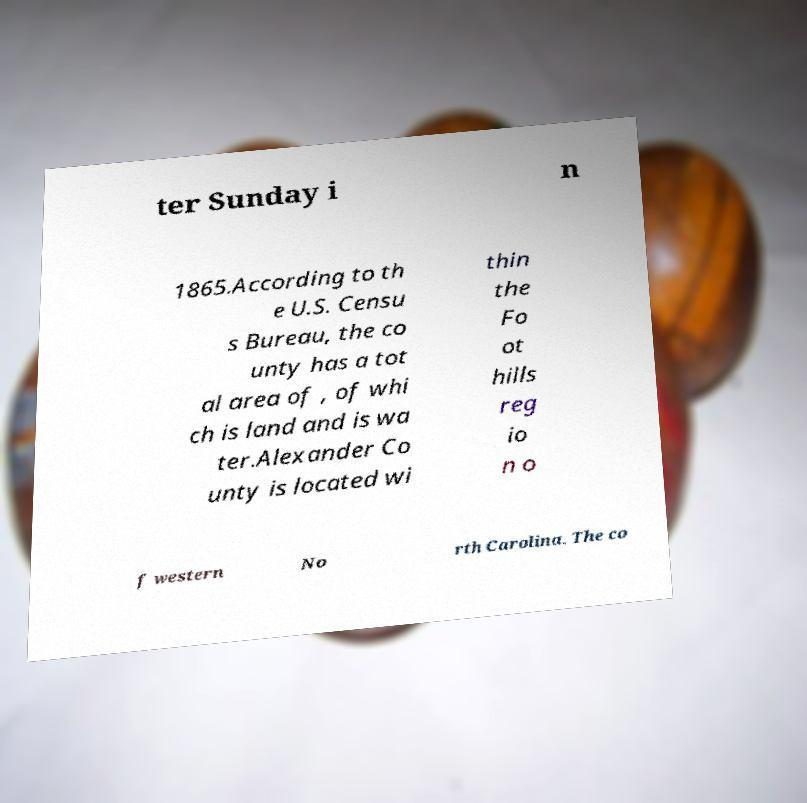Could you assist in decoding the text presented in this image and type it out clearly? ter Sunday i n 1865.According to th e U.S. Censu s Bureau, the co unty has a tot al area of , of whi ch is land and is wa ter.Alexander Co unty is located wi thin the Fo ot hills reg io n o f western No rth Carolina. The co 